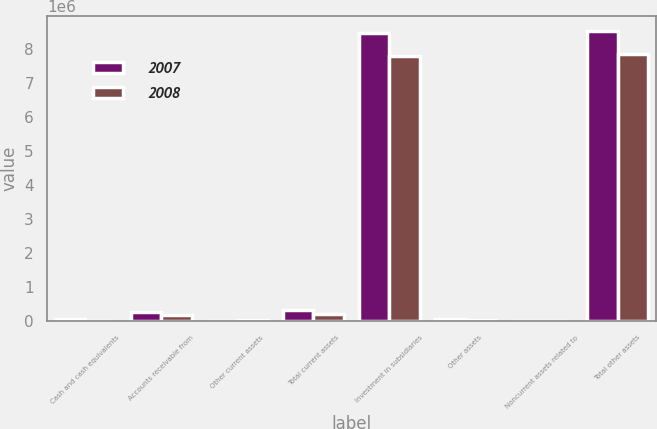Convert chart. <chart><loc_0><loc_0><loc_500><loc_500><stacked_bar_chart><ecel><fcel>Cash and cash equivalents<fcel>Accounts receivable from<fcel>Other current assets<fcel>Total current assets<fcel>Investment in subsidiaries<fcel>Other assets<fcel>Noncurrent assets related to<fcel>Total other assets<nl><fcel>2007<fcel>51778<fcel>275077<fcel>6573<fcel>333428<fcel>8.465e+06<fcel>61675<fcel>15914<fcel>8.54259e+06<nl><fcel>2008<fcel>3161<fcel>187522<fcel>29313<fcel>219996<fcel>7.79057e+06<fcel>40460<fcel>16926<fcel>7.84796e+06<nl></chart> 